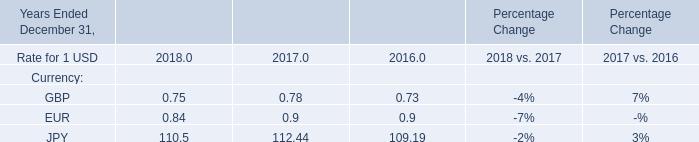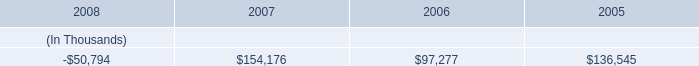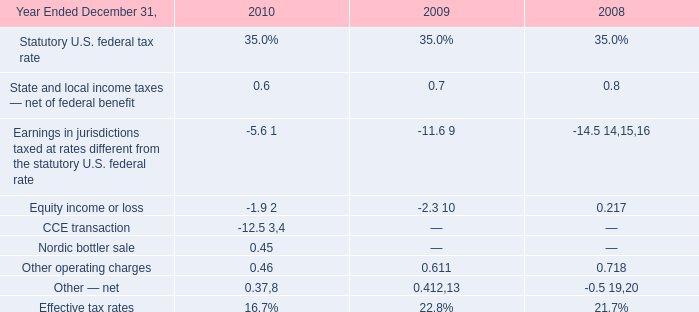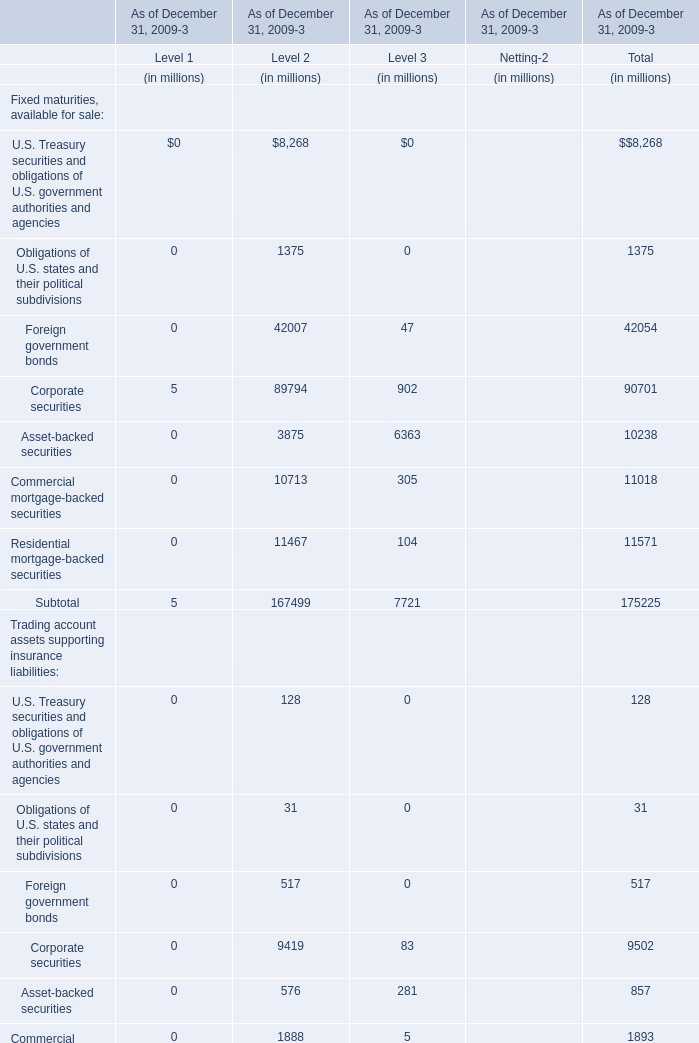What was the sum of the Total assets for Level 3 as of December 31, 2009 ? (in million) 
Answer: 22912. 